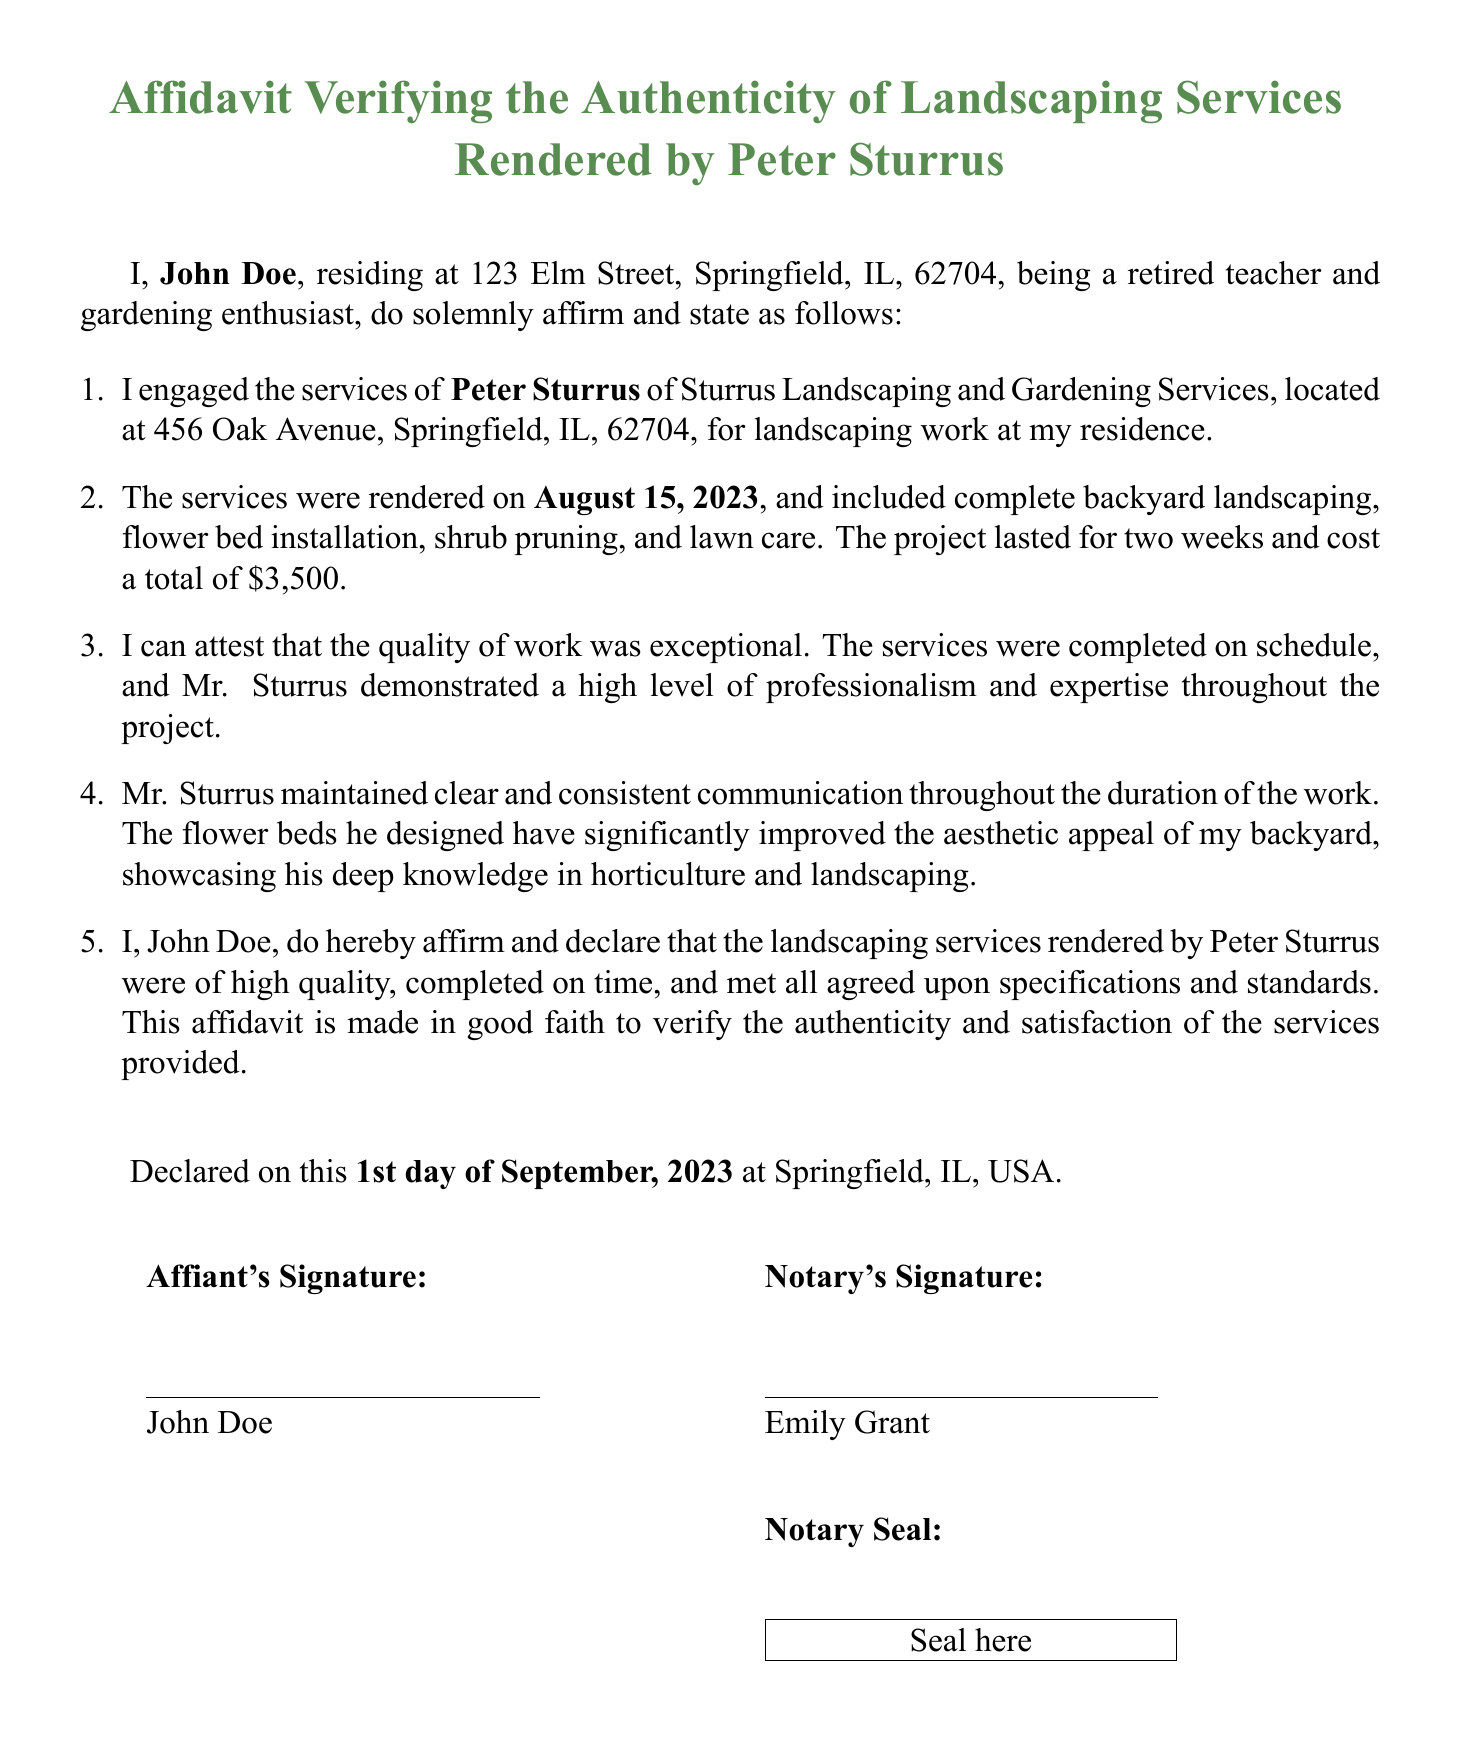What is the affiant's name? The affiant is identified as John Doe in the document.
Answer: John Doe What is the date the services were rendered? The document states that the services were rendered on August 15, 2023.
Answer: August 15, 2023 What is the total cost of the landscaping project? The total cost mentioned for the project is $3,500.
Answer: $3,500 Who is the notary for the affidavit? The notary who signed the affidavit is Emily Grant.
Answer: Emily Grant What is one service included in the landscaping work? The document lists flower bed installation as one of the services provided.
Answer: Flower bed installation Why is the affidavit being made? The affidavit is made to verify the authenticity and satisfaction of the services provided by Peter Sturrus.
Answer: To verify authenticity and satisfaction How long did the landscaping project last? It states that the project lasted for two weeks.
Answer: Two weeks What is the affiant's address? The affiant’s address is 123 Elm Street, Springfield, IL, 62704.
Answer: 123 Elm Street, Springfield, IL, 62704 What is the name of the landscaping service provider? The landscaping service provider is identified as Sturrus Landscaping and Gardening Services.
Answer: Sturrus Landscaping and Gardening Services 